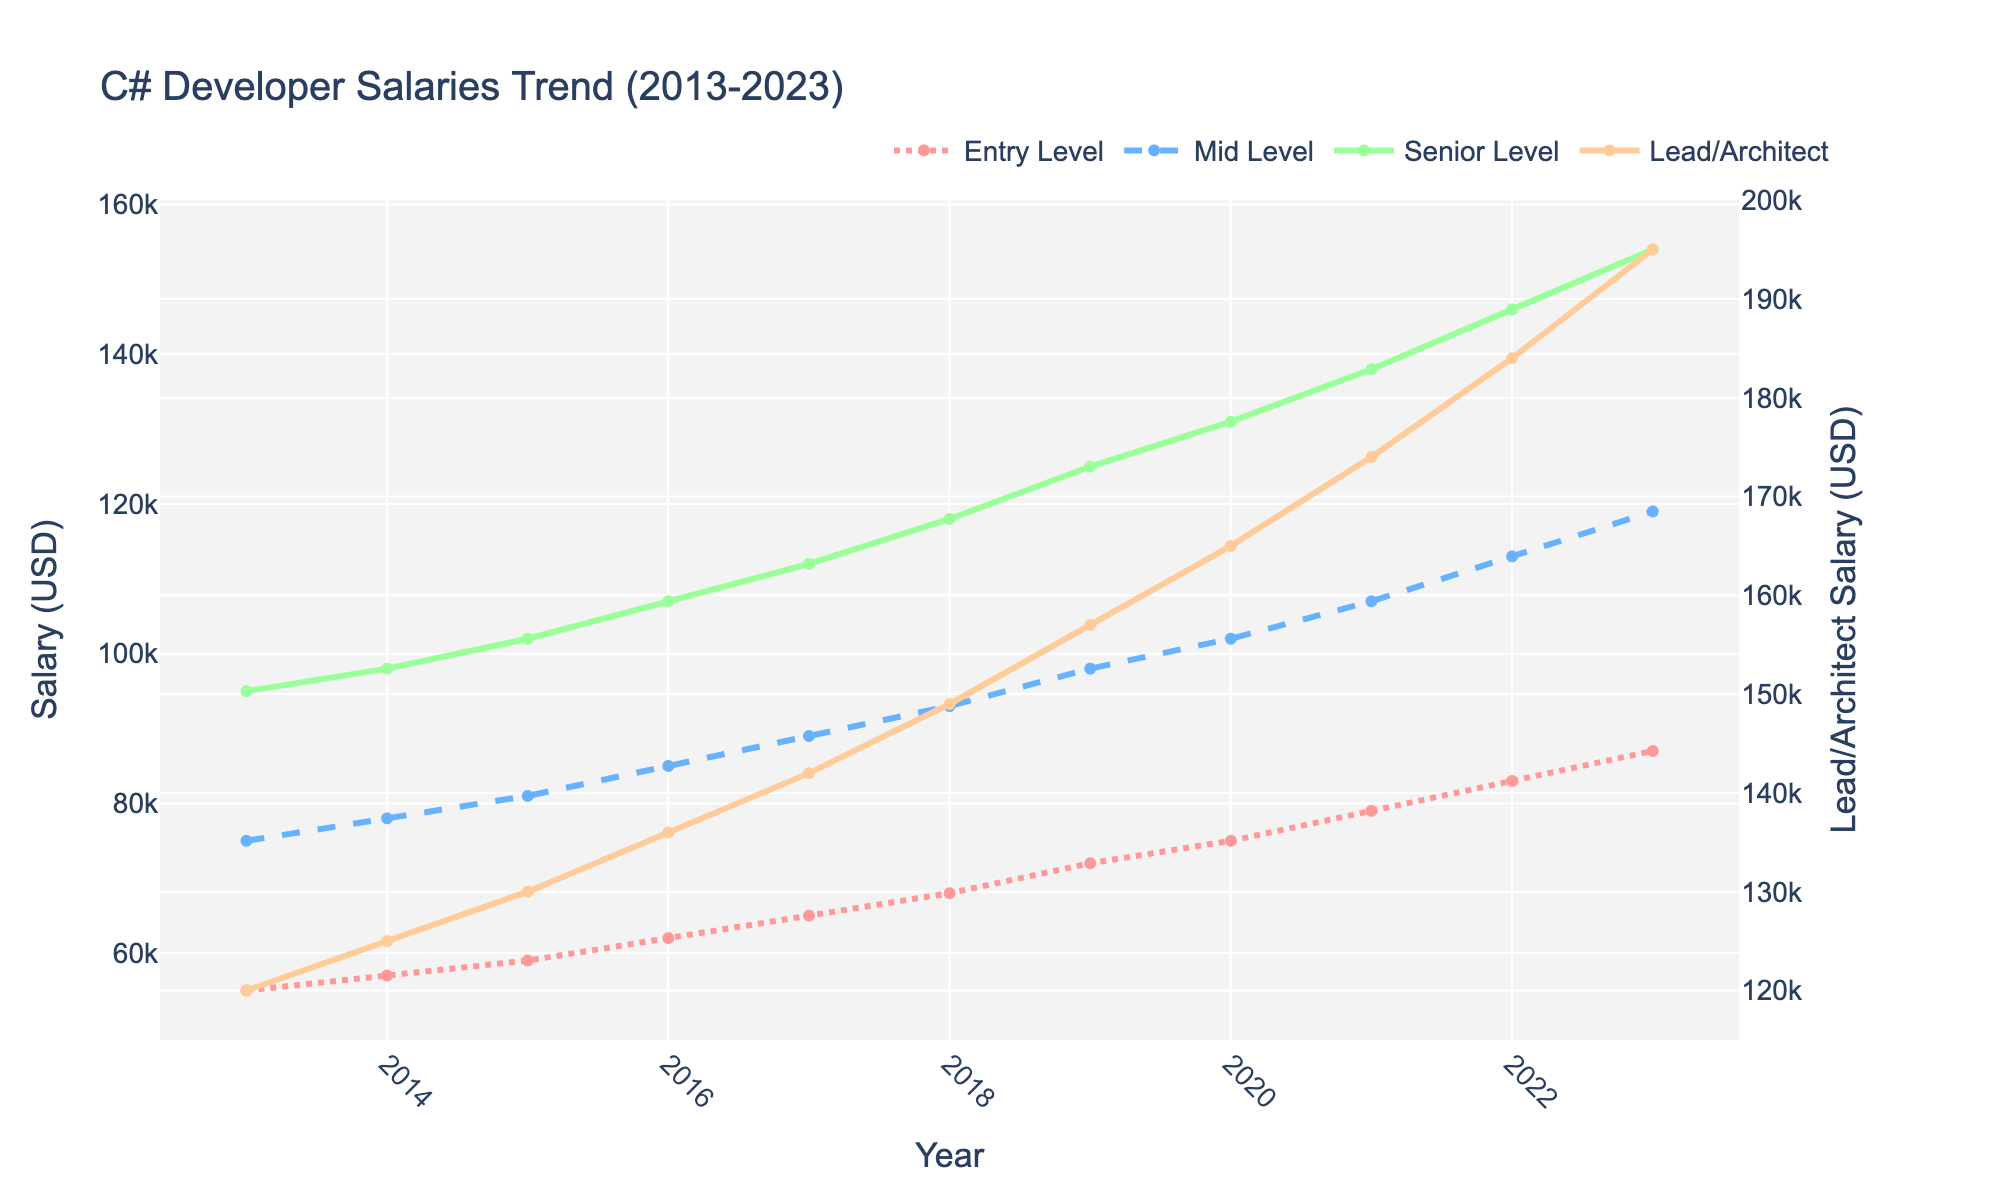What is the salary difference between a Senior Level developer and an Entry Level developer in 2023? In 2023, the Senior Level salary is $154,000 and the Entry Level salary is $87,000. The difference is $154,000 - $87,000 = $67,000.
Answer: $67,000 Which experience level had the highest salary growth from 2013 to 2023? Calculate the salary growth for each experience level: Entry Level ($87,000 - $55,000 = $32,000), Mid Level ($119,000 - $75,000 = $44,000), Senior Level ($154,000 - $95,000 = $59,000), and Lead/Architect ($195,000 - $120,000 = $75,000). The highest growth is for Lead/Architect with $75,000.
Answer: Lead/Architect In which year did Mid Level developers cross the $100,000 salary mark? Referring to the graph, the Mid Level salary crossed the $100,000 mark in 2020.
Answer: 2020 What is the average salary of Lead/Architect from 2013 to 2023? Sum the Lead/Architect salaries from 2013 to 2023 and divide by the number of years: ($120,000 + $125,000 + $130,000 + $136,000 + $142,000 + $149,000 + $157,000 + $165,000 + $174,000 + $184,000 + $195,000)/11. The sum is $1,777,000 and the average is $1,777,000 / 11 ≈ $161,545.
Answer: $161,545 Which experience level shows the least fluctuation in salary growth over the years? Visual inspection of the graph suggests that Entry Level developers show the most consistent and gradual increase without sharp jumps or drops compared to other levels.
Answer: Entry Level How much did the salary for Mid Level developers increase from 2015 to 2020? In 2015, the Mid Level salary was $81,000, and in 2020 it was $102,000. The increase is $102,000 - $81,000 = $21,000.
Answer: $21,000 What is the trend of Lead/Architect salaries after 2018? The graph shows a consistent upward trend in Lead/Architect salaries after 2018, rising from $149,000 in 2018 to $195,000 in 2023.
Answer: Upward trend Which year shows a major spike in salary for Senior Level developers? Referring to the graph, a notable spike for Senior Level developers occurs between 2018 and 2019, with salaries rising from $118,000 to $125,000.
Answer: 2019 What is the median salary of Entry Level developers from 2013 to 2023? List salaries for Entry Level from 2013 to 2023: $55,000, $57,000, $59,000, $62,000, $65,000, $68,000, $72,000, $75,000, $79,000, $83,000, $87,000. The median value, the middle number in this ordered list, is $68,000.
Answer: $68,000 By how much did the Senior Level salary increase from 2016 to 2023? In 2016, the Senior Level salary was $107,000, and in 2023 it was $154,000. The increase is $154,000 - $107,000 = $47,000.
Answer: $47,000 